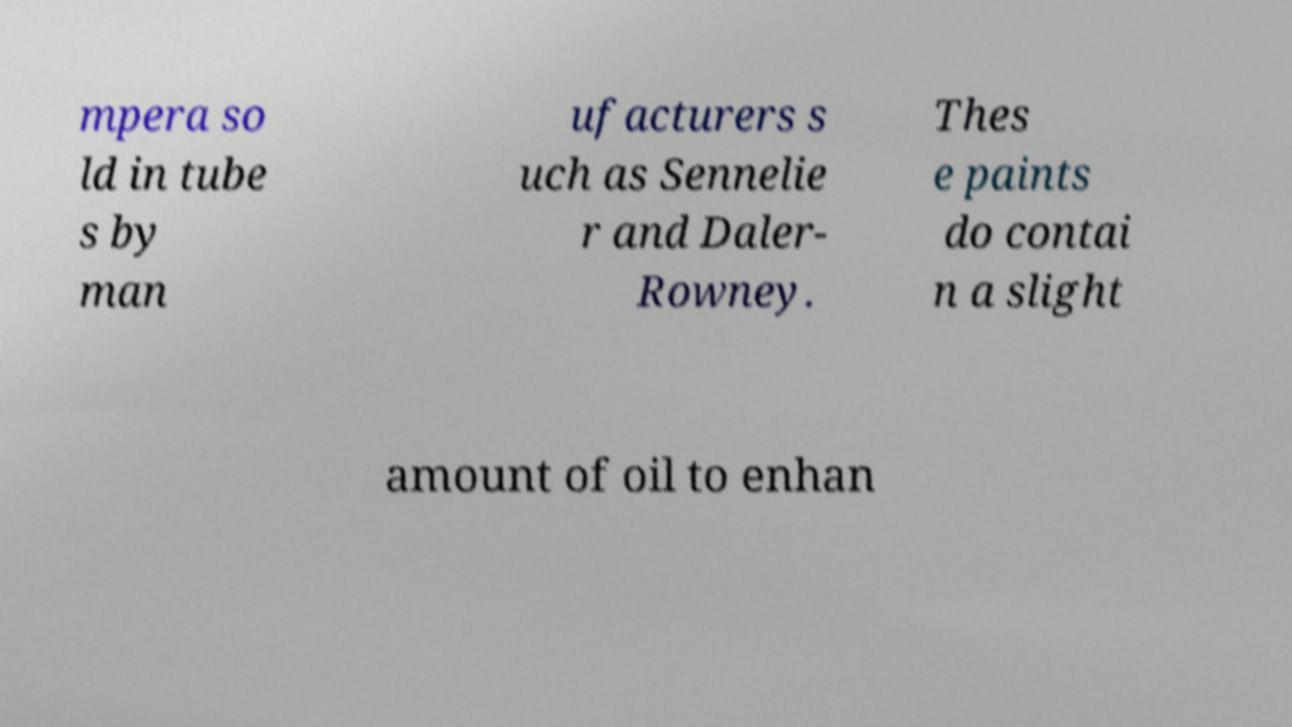Please read and relay the text visible in this image. What does it say? mpera so ld in tube s by man ufacturers s uch as Sennelie r and Daler- Rowney. Thes e paints do contai n a slight amount of oil to enhan 